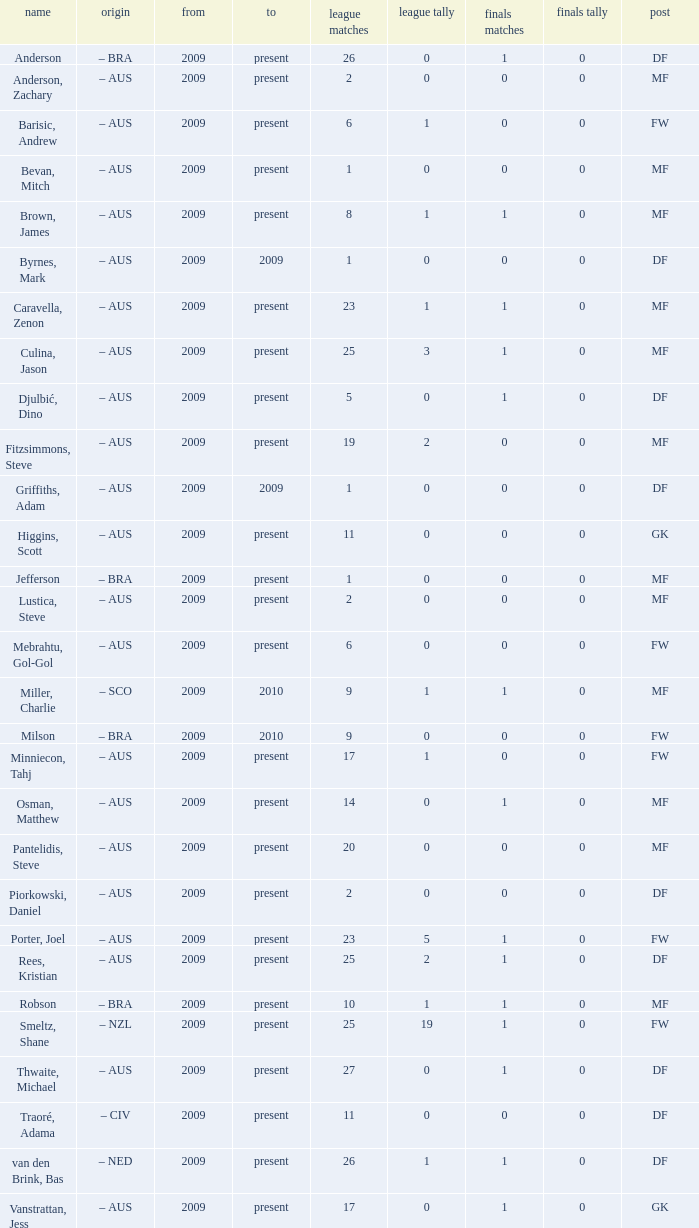Name the to for 19 league apps Present. 